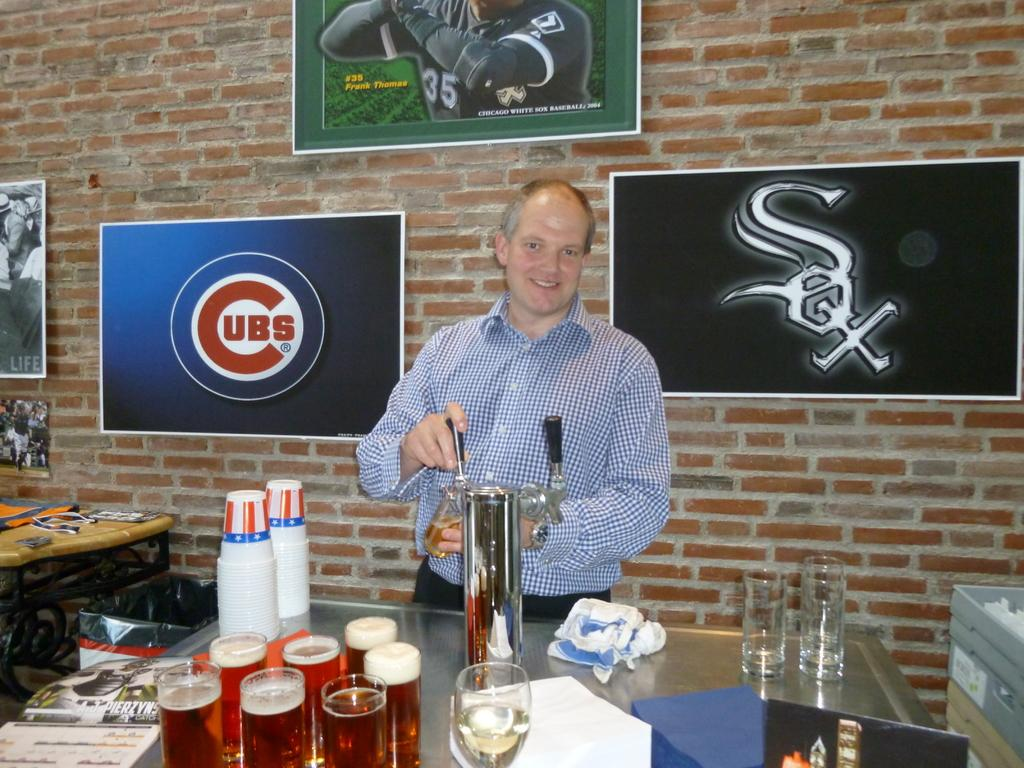<image>
Relay a brief, clear account of the picture shown. A man stands at a tabl with a Cubs picture behind him. 